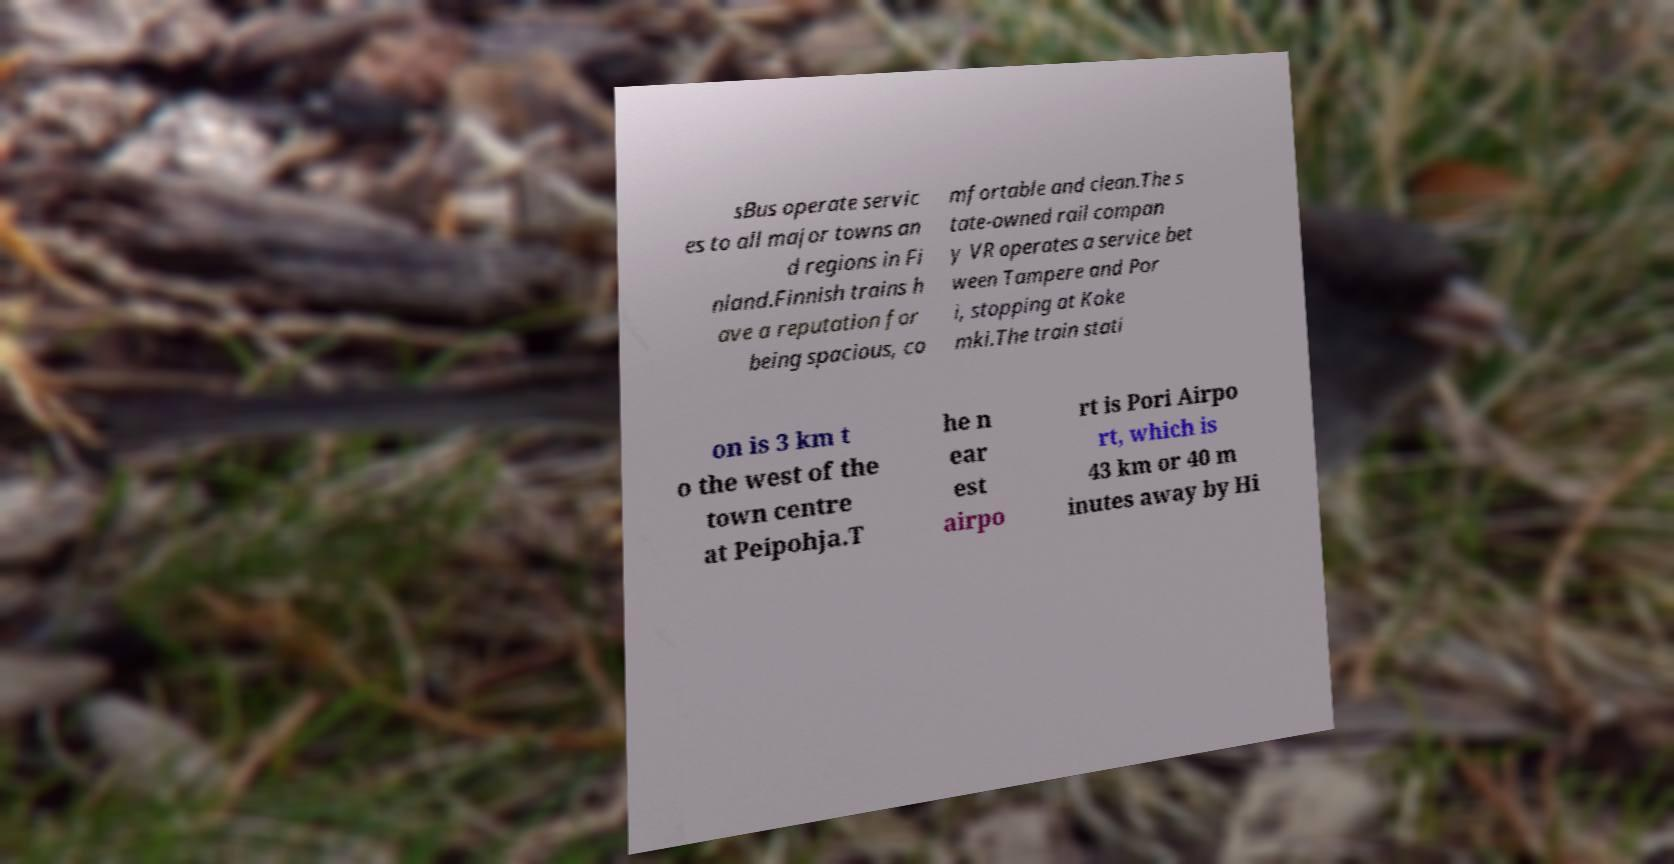There's text embedded in this image that I need extracted. Can you transcribe it verbatim? sBus operate servic es to all major towns an d regions in Fi nland.Finnish trains h ave a reputation for being spacious, co mfortable and clean.The s tate-owned rail compan y VR operates a service bet ween Tampere and Por i, stopping at Koke mki.The train stati on is 3 km t o the west of the town centre at Peipohja.T he n ear est airpo rt is Pori Airpo rt, which is 43 km or 40 m inutes away by Hi 